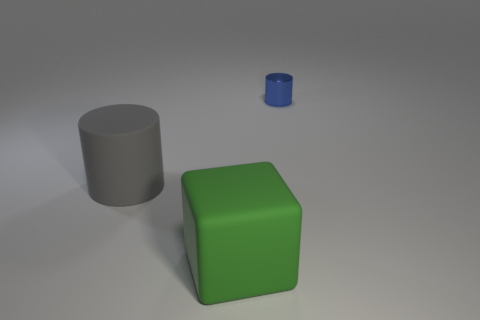Is there any other thing that is the same material as the small blue cylinder?
Give a very brief answer. No. There is a block that is the same material as the big gray cylinder; what is its color?
Provide a short and direct response. Green. There is a rubber thing on the right side of the gray thing; how big is it?
Make the answer very short. Large. Are there fewer big green matte objects right of the big green matte object than green matte things?
Your answer should be very brief. Yes. Does the small object have the same color as the large cube?
Your response must be concise. No. Is there anything else that is the same shape as the gray thing?
Your answer should be very brief. Yes. Are there fewer rubber cylinders than tiny yellow rubber balls?
Offer a very short reply. No. There is a cylinder that is to the right of the cylinder in front of the blue cylinder; what is its color?
Offer a terse response. Blue. The cylinder to the left of the large rubber object to the right of the large thing behind the block is made of what material?
Give a very brief answer. Rubber. There is a object that is on the right side of the green cube; is it the same size as the matte cylinder?
Provide a short and direct response. No. 